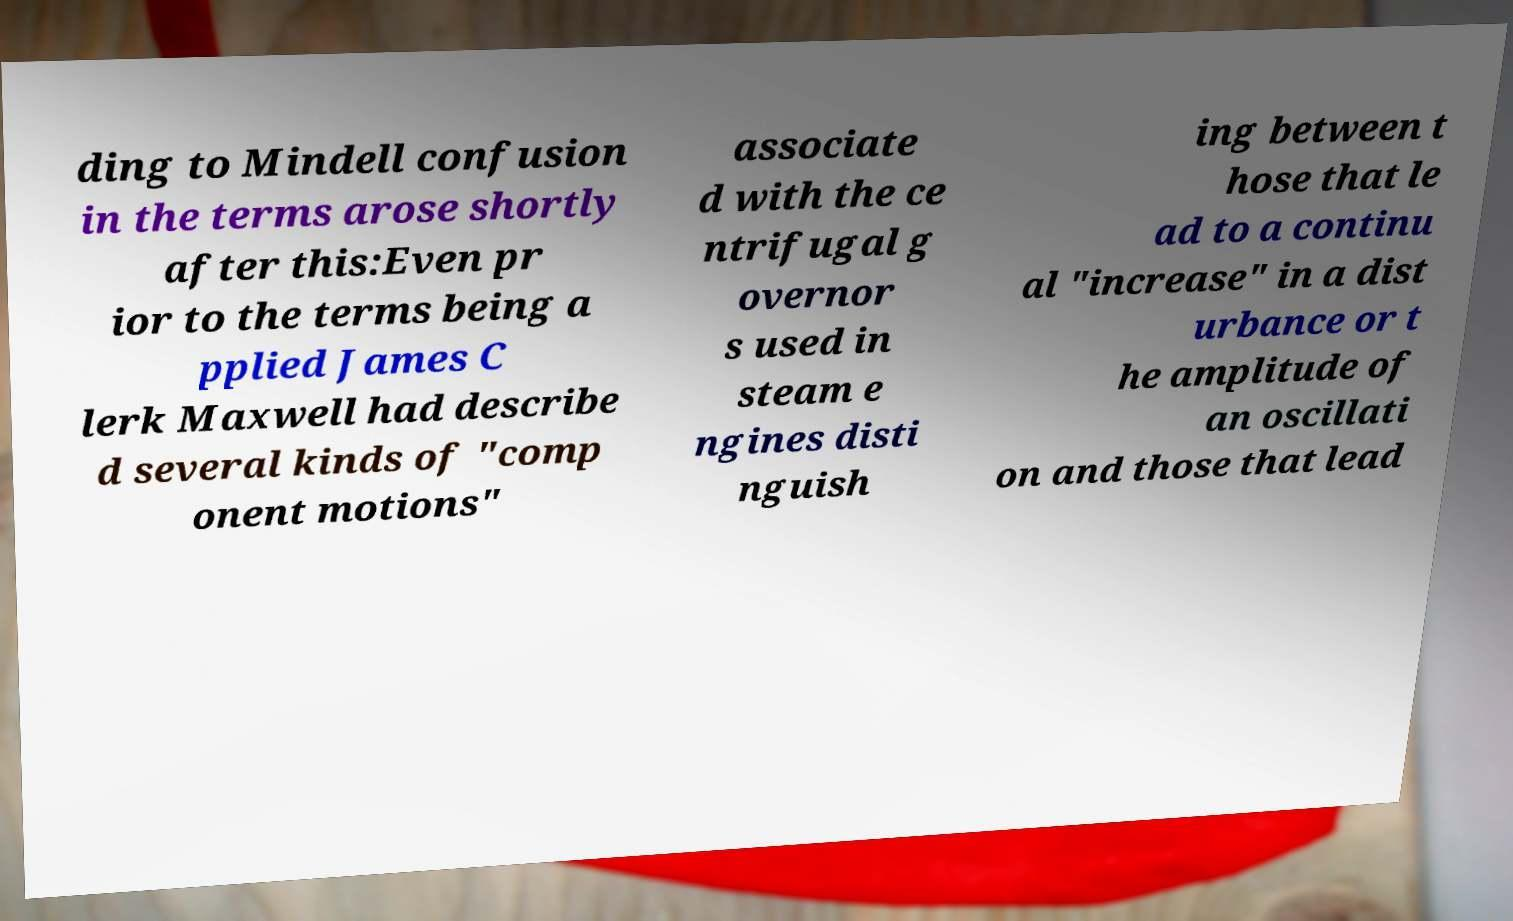I need the written content from this picture converted into text. Can you do that? ding to Mindell confusion in the terms arose shortly after this:Even pr ior to the terms being a pplied James C lerk Maxwell had describe d several kinds of "comp onent motions" associate d with the ce ntrifugal g overnor s used in steam e ngines disti nguish ing between t hose that le ad to a continu al "increase" in a dist urbance or t he amplitude of an oscillati on and those that lead 